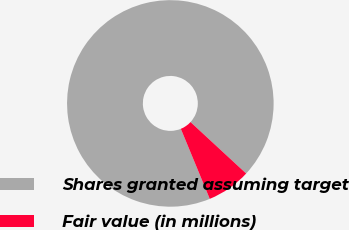Convert chart to OTSL. <chart><loc_0><loc_0><loc_500><loc_500><pie_chart><fcel>Shares granted assuming target<fcel>Fair value (in millions)<nl><fcel>93.11%<fcel>6.89%<nl></chart> 